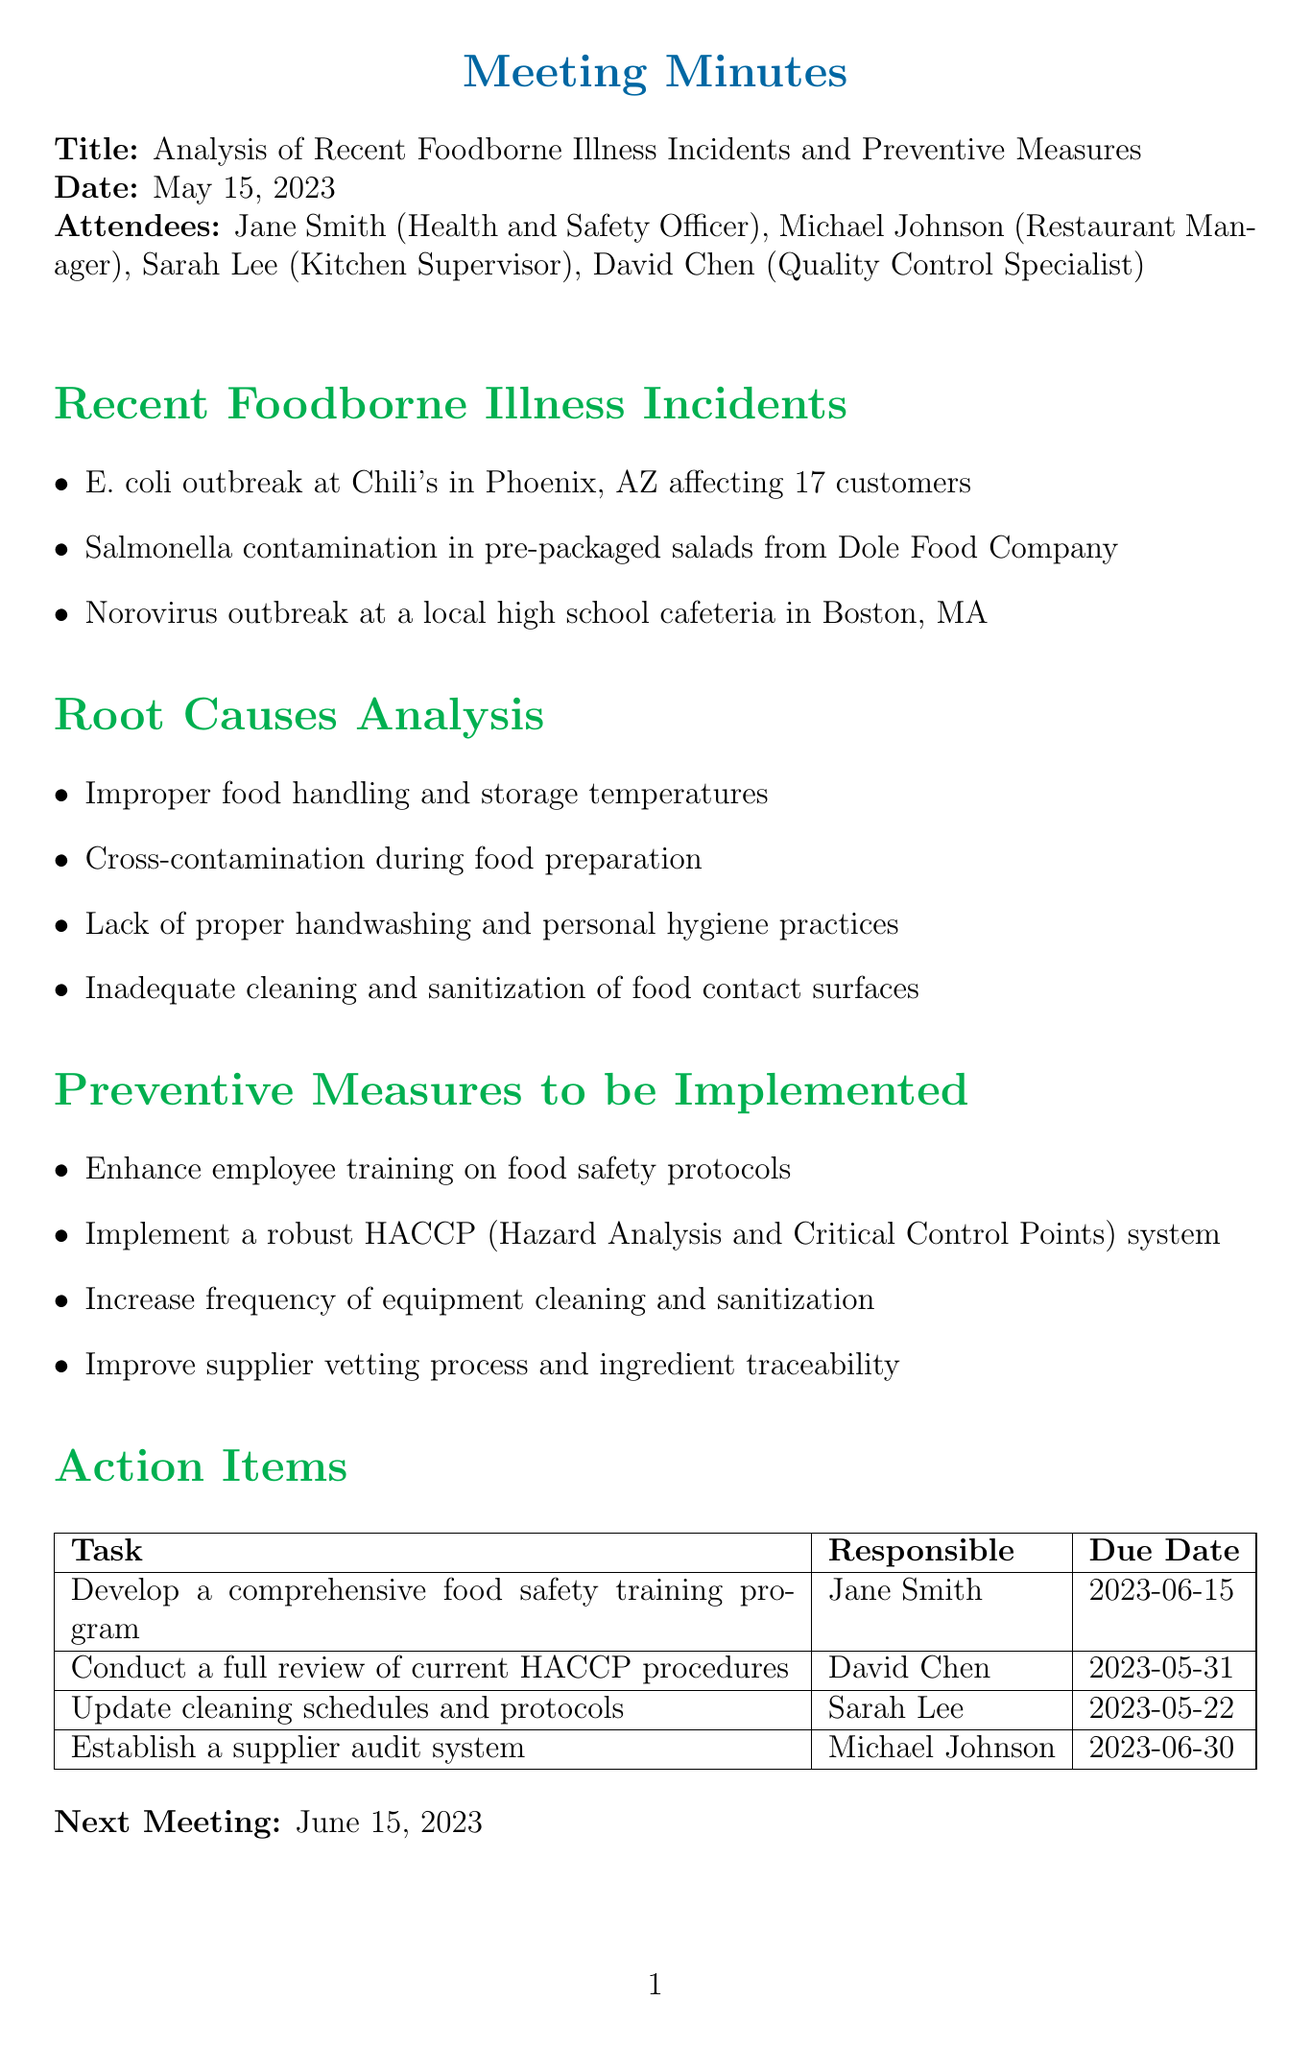What is the title of the meeting? The title is stated at the beginning of the document.
Answer: Analysis of Recent Foodborne Illness Incidents and Preventive Measures Who is responsible for developing the food safety training program? This information is listed in the action items section of the document.
Answer: Jane Smith What was the due date for updating cleaning schedules? The due date can be found in the action items table.
Answer: 2023-05-22 How many customers were affected by the E. coli outbreak? This number is provided in the recent foodborne illness incidents section.
Answer: 17 customers Which company was involved in the salmonella contamination? The company name is mentioned in the details of recent incidents.
Answer: Dole Food Company What preventive measure involves improving a vetting process? This measure is outlined in the preventive measures section of the document.
Answer: Supplier vetting process What other foodborne illness was mentioned besides E. coli and salmonella? This is identified in the recent incidents and requires recalling the listed illnesses.
Answer: Norovirus What is the next meeting date? The next meeting date is explicitly stated in the document.
Answer: June 15, 2023 How often should equipment cleaning and sanitization be increased? This detail is included in the preventive measures section under proposed actions.
Answer: Increase frequency 